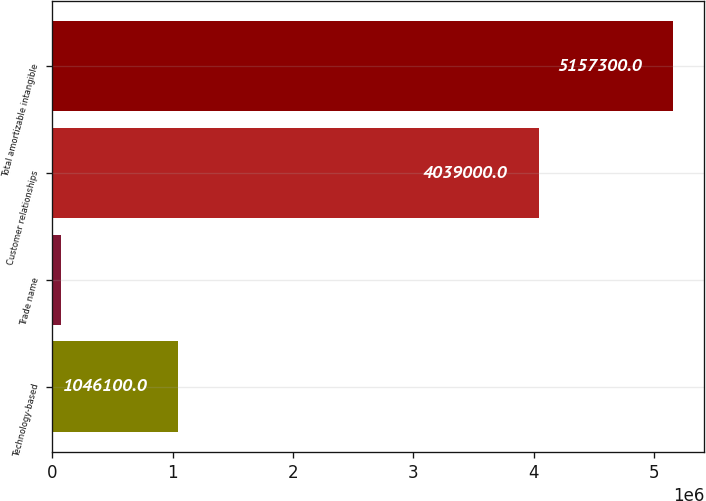Convert chart. <chart><loc_0><loc_0><loc_500><loc_500><bar_chart><fcel>Technology-based<fcel>Trade name<fcel>Customer relationships<fcel>Total amortizable intangible<nl><fcel>1.0461e+06<fcel>72200<fcel>4.039e+06<fcel>5.1573e+06<nl></chart> 